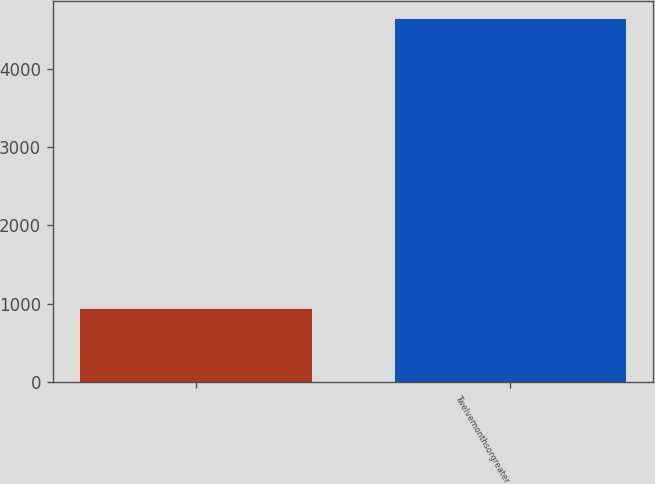Convert chart to OTSL. <chart><loc_0><loc_0><loc_500><loc_500><bar_chart><ecel><fcel>Twelvemonthsorgreater<nl><fcel>937<fcel>4634<nl></chart> 